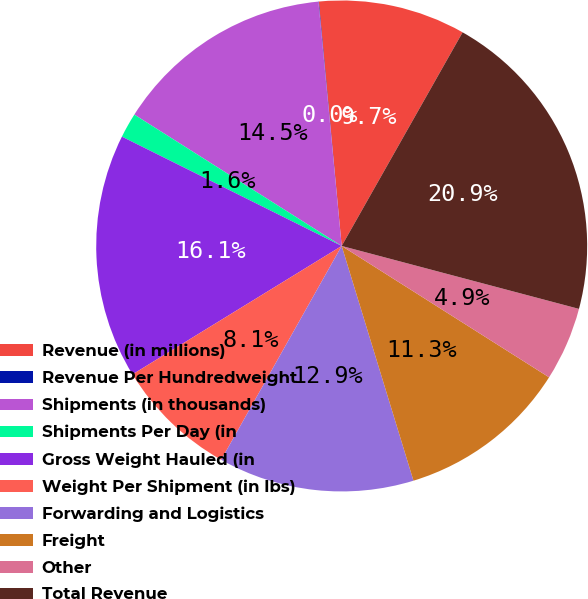<chart> <loc_0><loc_0><loc_500><loc_500><pie_chart><fcel>Revenue (in millions)<fcel>Revenue Per Hundredweight<fcel>Shipments (in thousands)<fcel>Shipments Per Day (in<fcel>Gross Weight Hauled (in<fcel>Weight Per Shipment (in lbs)<fcel>Forwarding and Logistics<fcel>Freight<fcel>Other<fcel>Total Revenue<nl><fcel>9.68%<fcel>0.03%<fcel>14.5%<fcel>1.64%<fcel>16.11%<fcel>8.07%<fcel>12.89%<fcel>11.29%<fcel>4.86%<fcel>20.93%<nl></chart> 